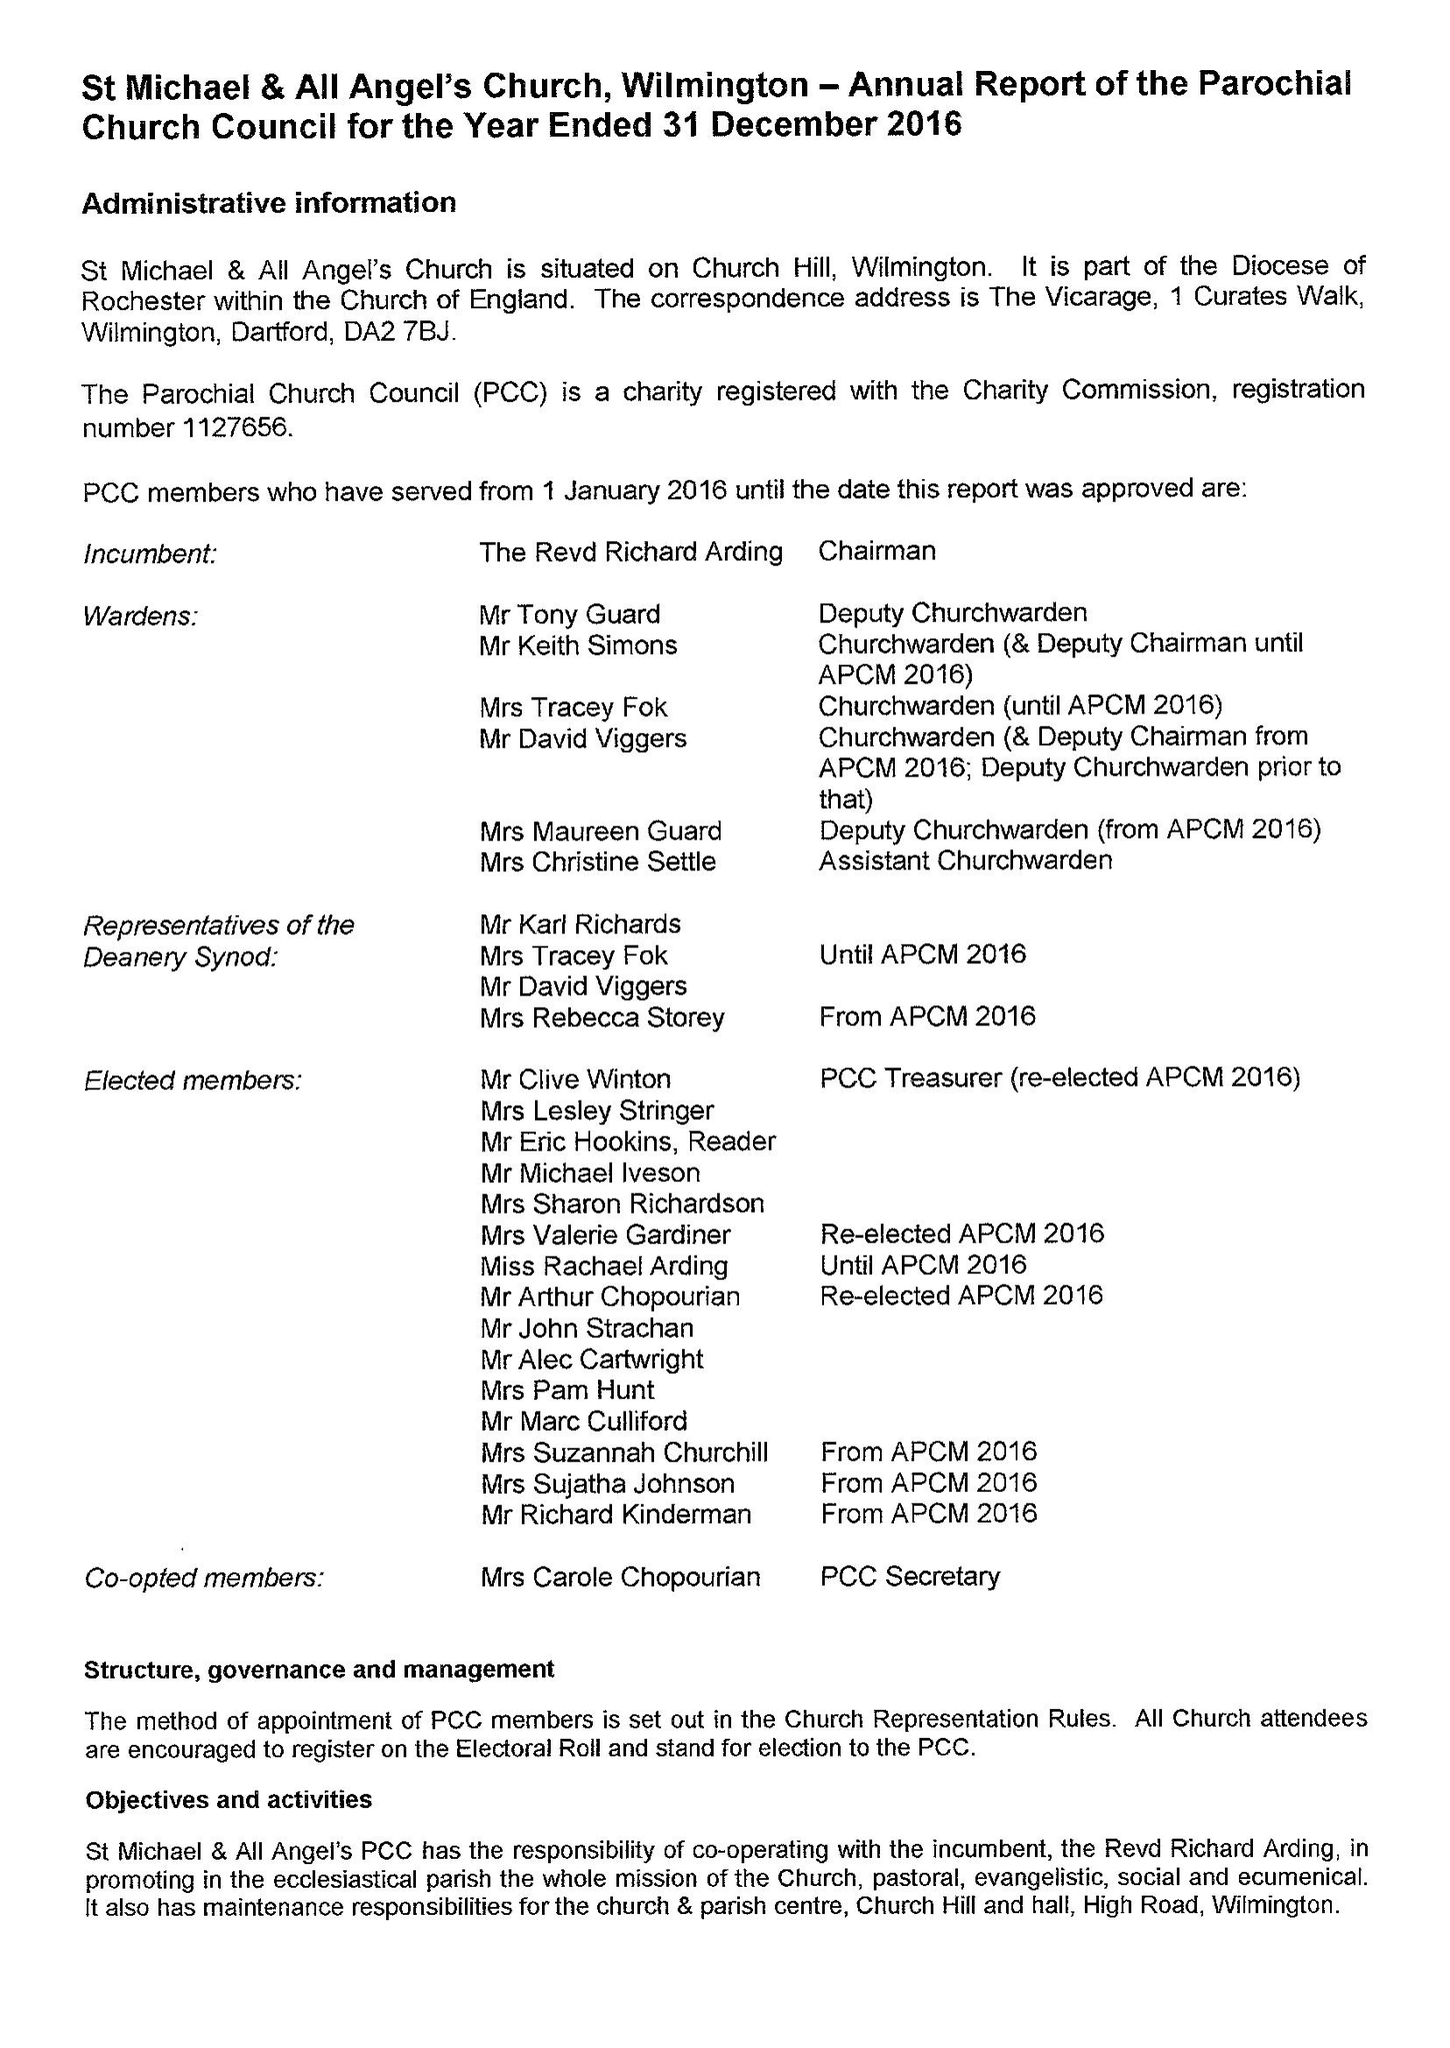What is the value for the spending_annually_in_british_pounds?
Answer the question using a single word or phrase. 135107.00 